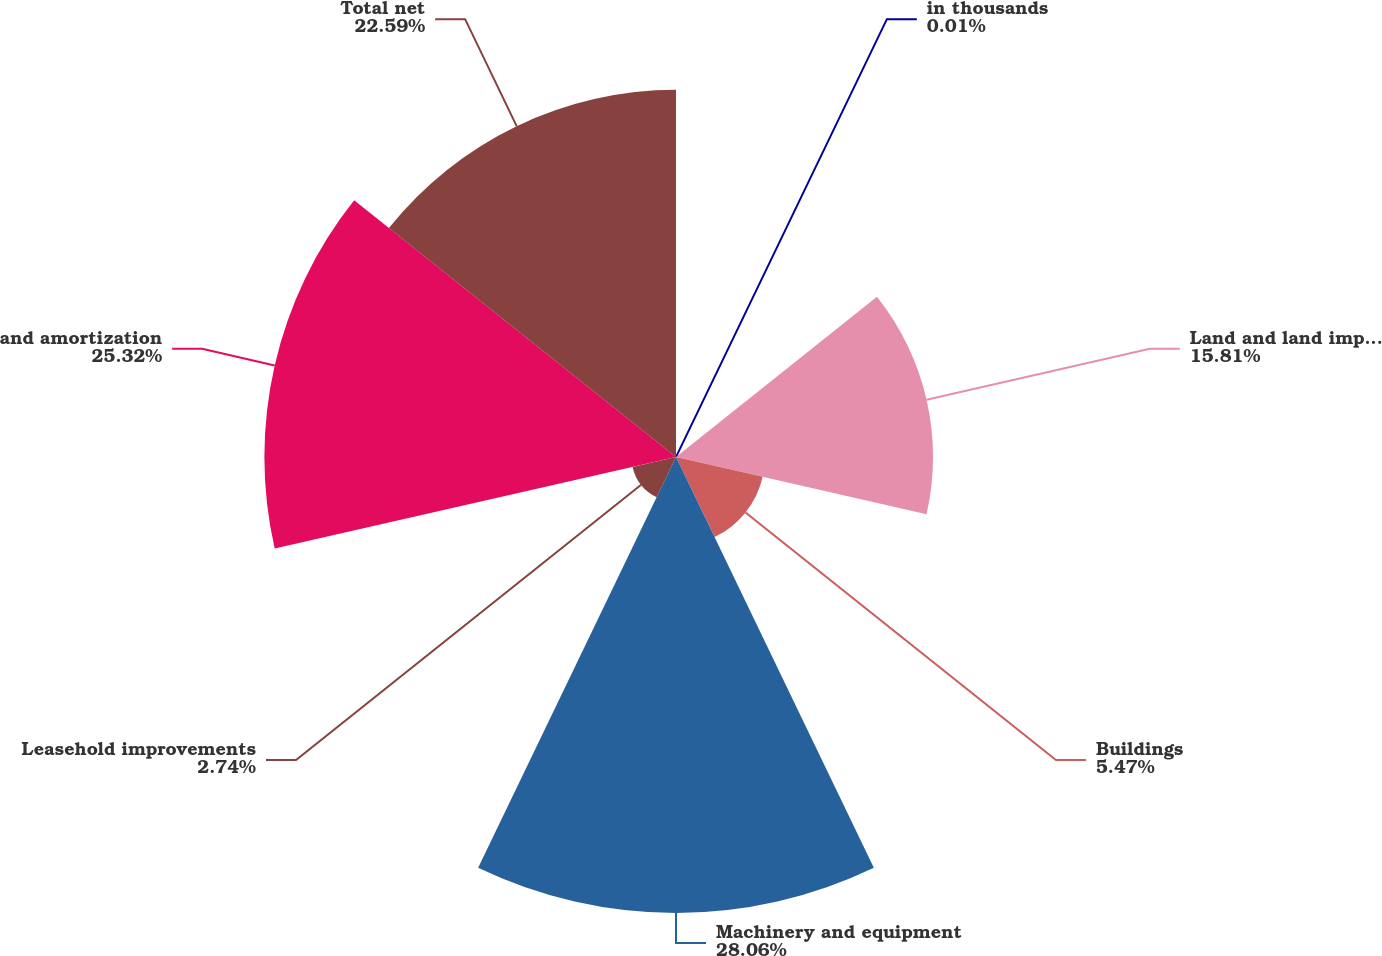Convert chart. <chart><loc_0><loc_0><loc_500><loc_500><pie_chart><fcel>in thousands<fcel>Land and land improvements ^1<fcel>Buildings<fcel>Machinery and equipment<fcel>Leasehold improvements<fcel>and amortization<fcel>Total net<nl><fcel>0.01%<fcel>15.81%<fcel>5.47%<fcel>28.05%<fcel>2.74%<fcel>25.32%<fcel>22.59%<nl></chart> 